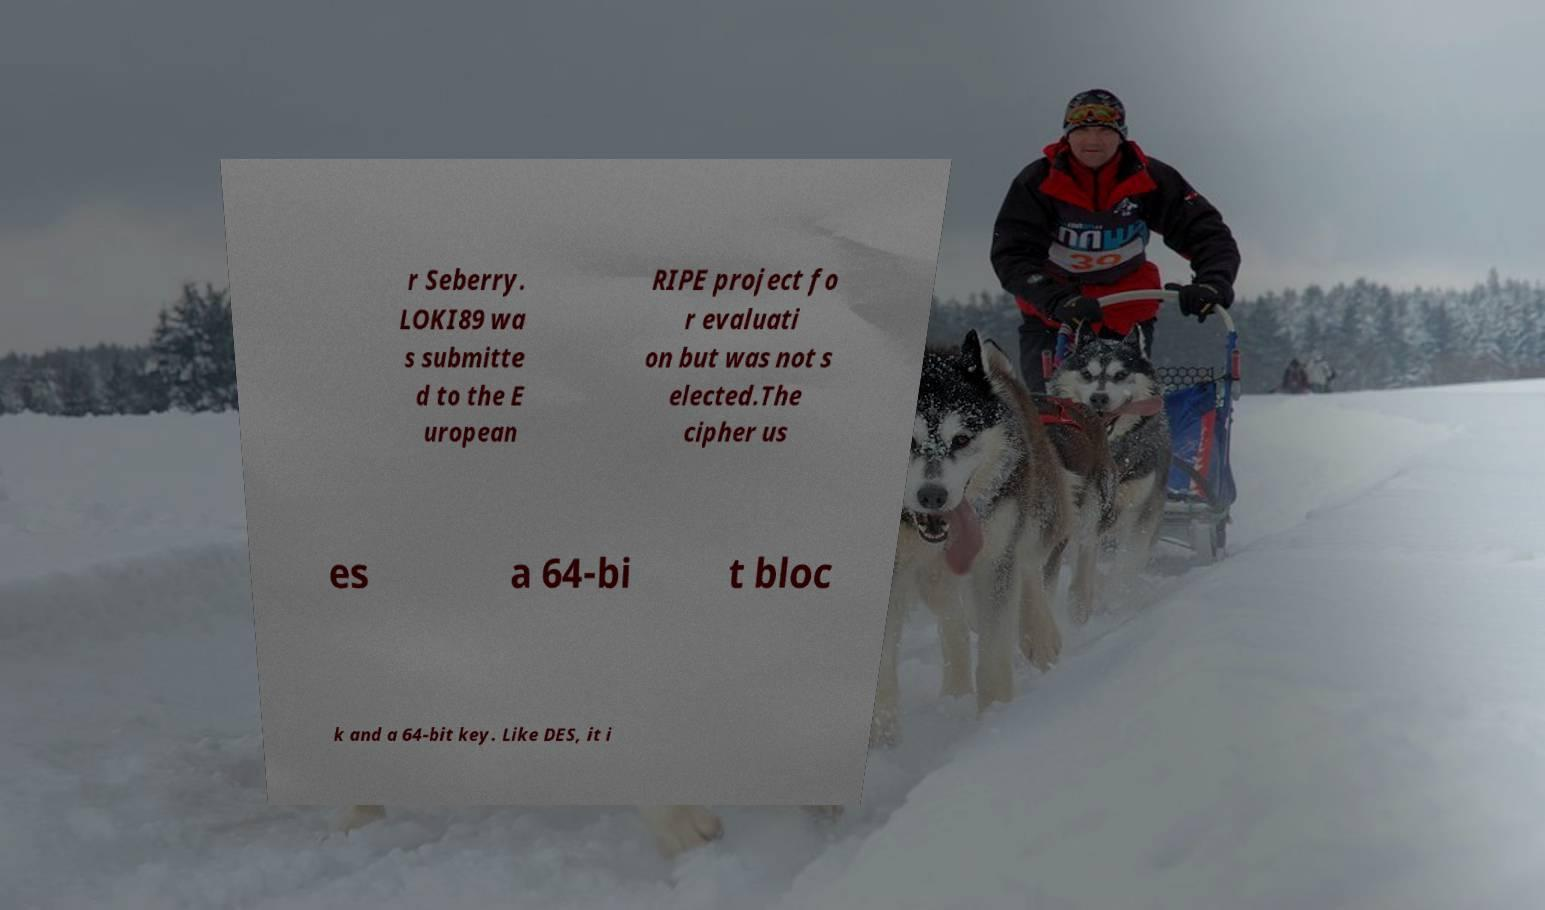Please read and relay the text visible in this image. What does it say? r Seberry. LOKI89 wa s submitte d to the E uropean RIPE project fo r evaluati on but was not s elected.The cipher us es a 64-bi t bloc k and a 64-bit key. Like DES, it i 